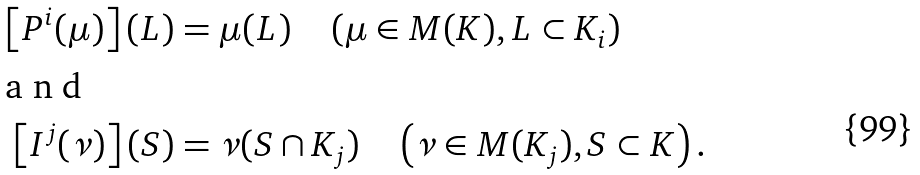<formula> <loc_0><loc_0><loc_500><loc_500>\left [ P ^ { i } ( \mu ) \right ] ( L ) & = \mu ( L ) \quad \left ( \mu \in M ( K ) , L \subset K _ { i } \right ) \\ \intertext { a n d } \left [ I ^ { j } ( \nu ) \right ] ( S ) & = \nu ( S \cap K _ { j } ) \quad \left ( \nu \in M ( K _ { j } ) , S \subset K \right ) .</formula> 